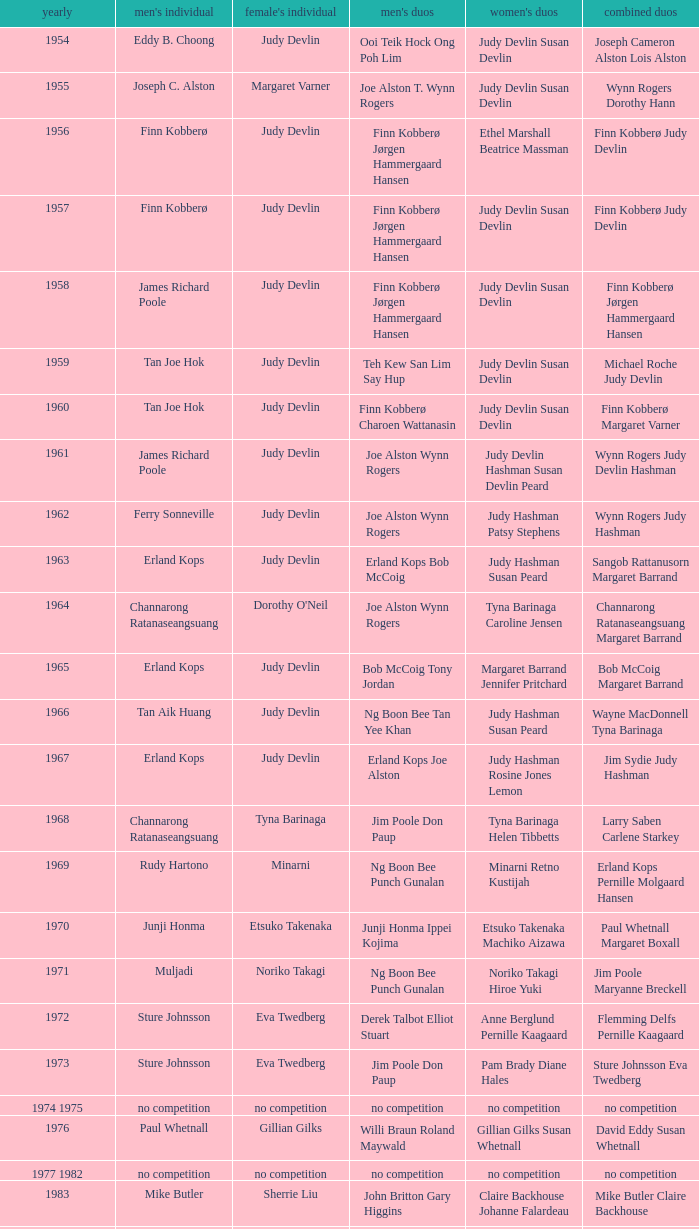Who were the men's doubles champions when the men's singles champion was muljadi? Ng Boon Bee Punch Gunalan. 